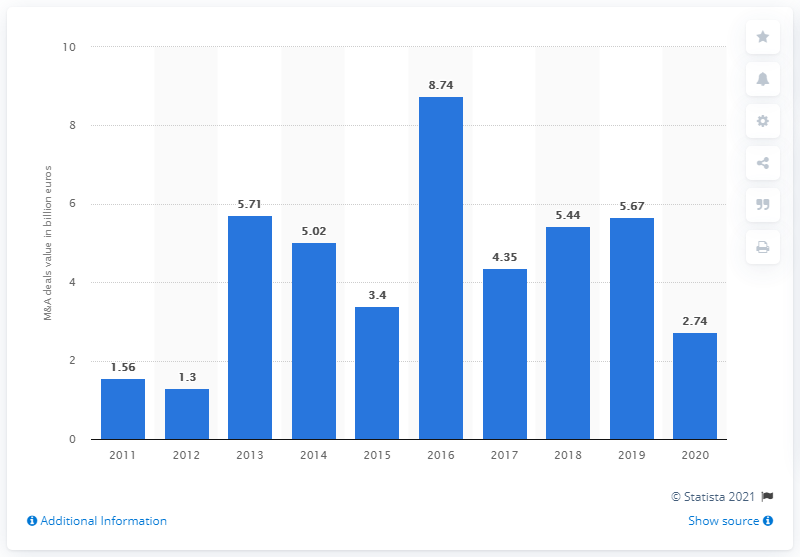Point out several critical features in this image. In 2016, the total value of merger and acquisition (M&A) deals was 8.74. 